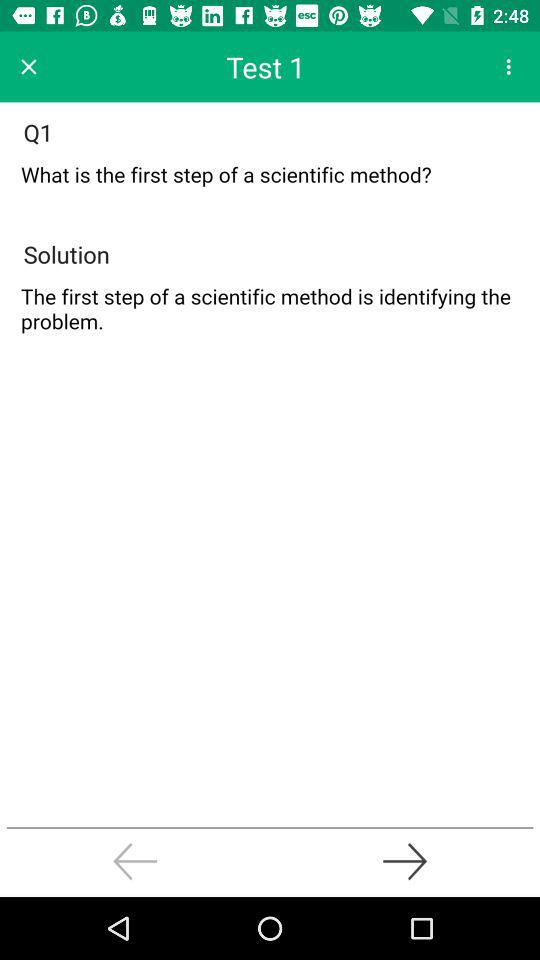What is the first step of a scientific method? The first step of a scientific method is to identify the problem. 